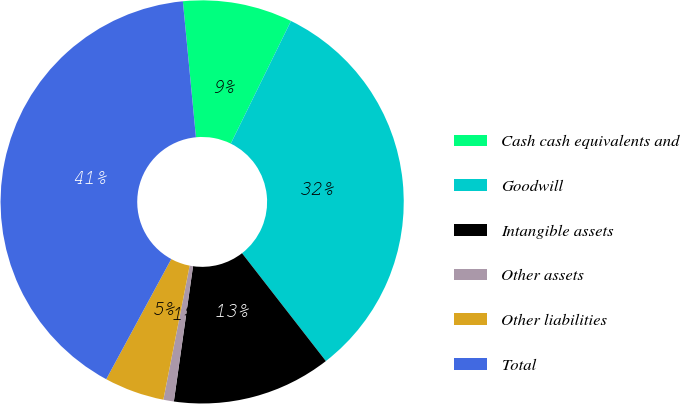<chart> <loc_0><loc_0><loc_500><loc_500><pie_chart><fcel>Cash cash equivalents and<fcel>Goodwill<fcel>Intangible assets<fcel>Other assets<fcel>Other liabilities<fcel>Total<nl><fcel>8.79%<fcel>32.22%<fcel>12.76%<fcel>0.84%<fcel>4.81%<fcel>40.58%<nl></chart> 